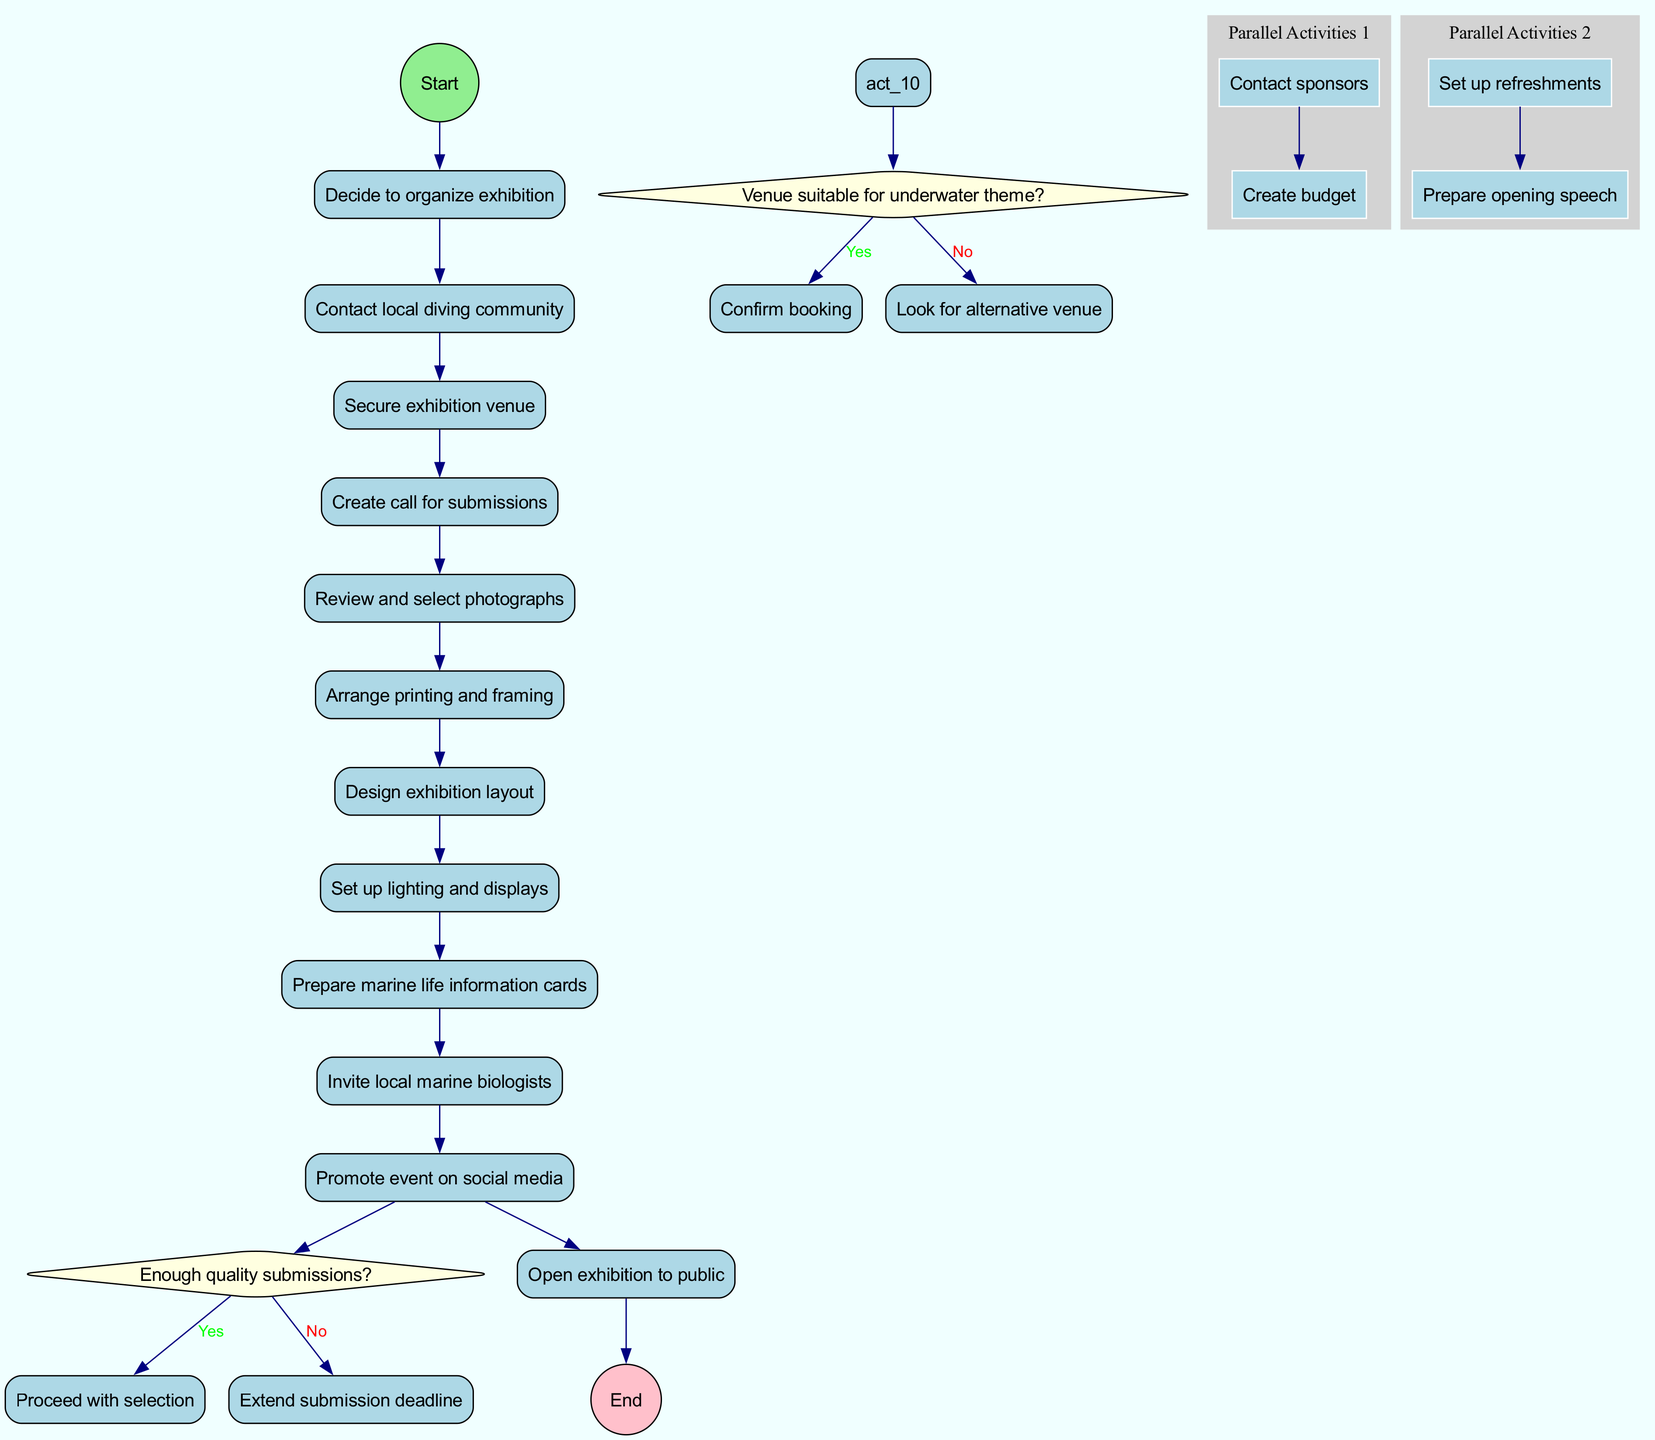What is the starting node of the diagram? The starting node is designated by the first node connected to the start circle. According to the diagram, it is "Decide to organize exhibition".
Answer: Decide to organize exhibition How many activities are listed in the diagram? The activities are enumerated within the diagram, and there are a total of 9 activities mentioned.
Answer: 9 What decision follows the activity "Review and select photographs"? The decision is indicated as the next step stemming from the activity "Review and select photographs". It leads to the question "Enough quality submissions?".
Answer: Enough quality submissions? What is the outcome if the venue is not suitable for the underwater theme? If the condition pans out as 'no', it points to the action of looking for an alternative venue, which is clearly defined in the diagram.
Answer: Look for alternative venue How many parallel activities are identified in the diagram? The diagram explicitly highlights that there are 2 sets of parallel activities under the same label, hence establishing it clearly.
Answer: 2 What action occurs if there are enough quality submissions? The 'yes' path from the decision node leads directly to "Proceed with selection", describing the action taken given sufficient submissions.
Answer: Proceed with selection Which activity occurs after "Design exhibition layout"? The direct relationship outlined in the diagram shows that following "Design exhibition layout", the activity "Set up lighting and displays" occurs.
Answer: Set up lighting and displays What is the final node of the diagram called? The final node is designated for the conclusion of the processes laid out in the diagram and is labeled as "Open exhibition to public".
Answer: Open exhibition to public What does the activity "Contact local diving community" initiate? This activity acts as the starting point and seamlessly flows into the next step, connecting to the subsequent activity, which is "Secure exhibition venue".
Answer: Secure exhibition venue 